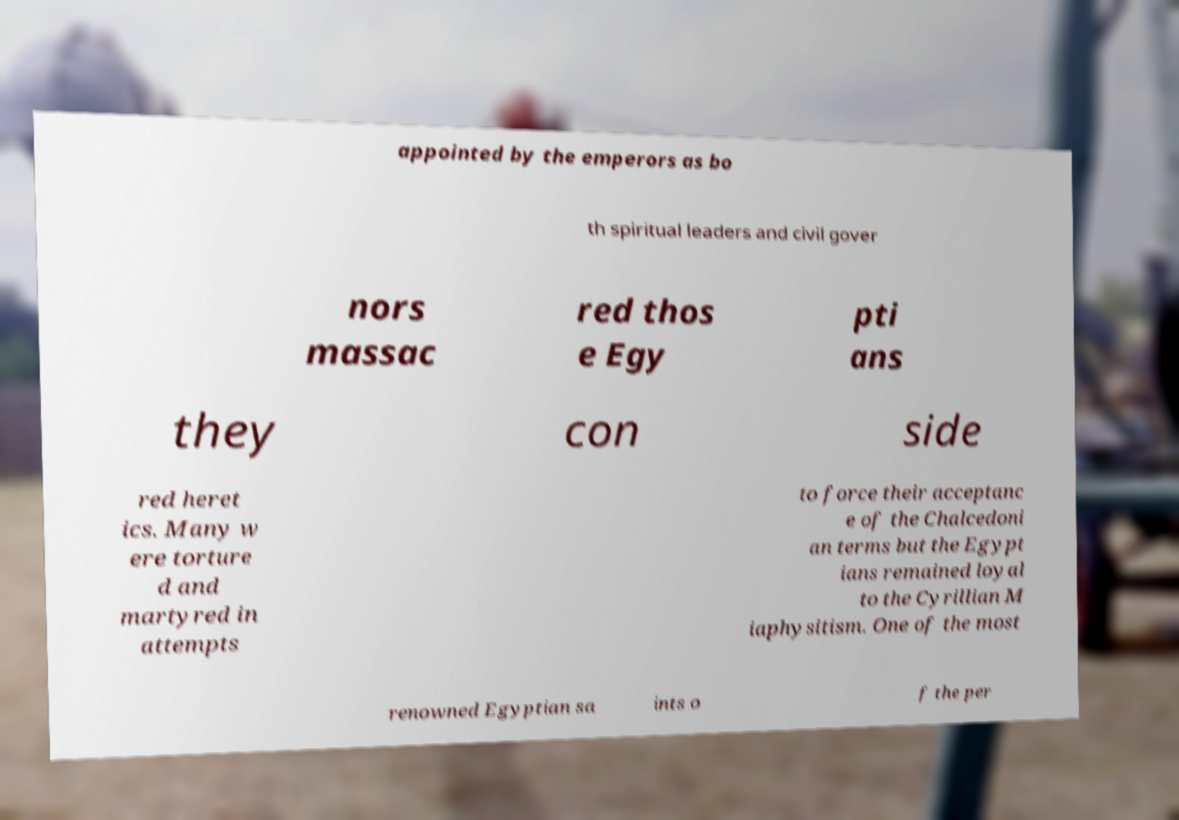Please identify and transcribe the text found in this image. appointed by the emperors as bo th spiritual leaders and civil gover nors massac red thos e Egy pti ans they con side red heret ics. Many w ere torture d and martyred in attempts to force their acceptanc e of the Chalcedoni an terms but the Egypt ians remained loyal to the Cyrillian M iaphysitism. One of the most renowned Egyptian sa ints o f the per 